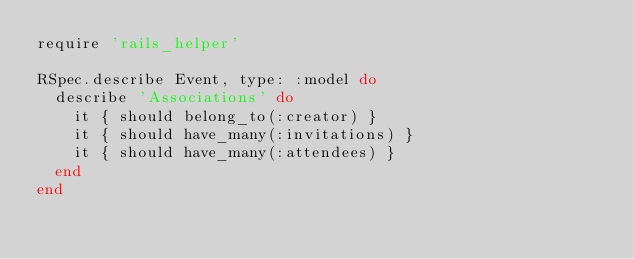Convert code to text. <code><loc_0><loc_0><loc_500><loc_500><_Ruby_>require 'rails_helper'

RSpec.describe Event, type: :model do
  describe 'Associations' do
    it { should belong_to(:creator) }
    it { should have_many(:invitations) }
    it { should have_many(:attendees) }
  end
end
</code> 